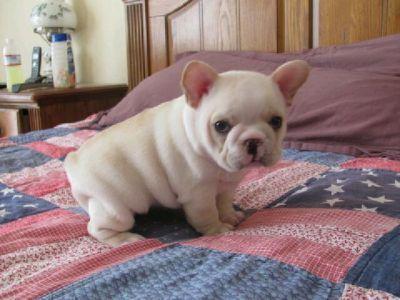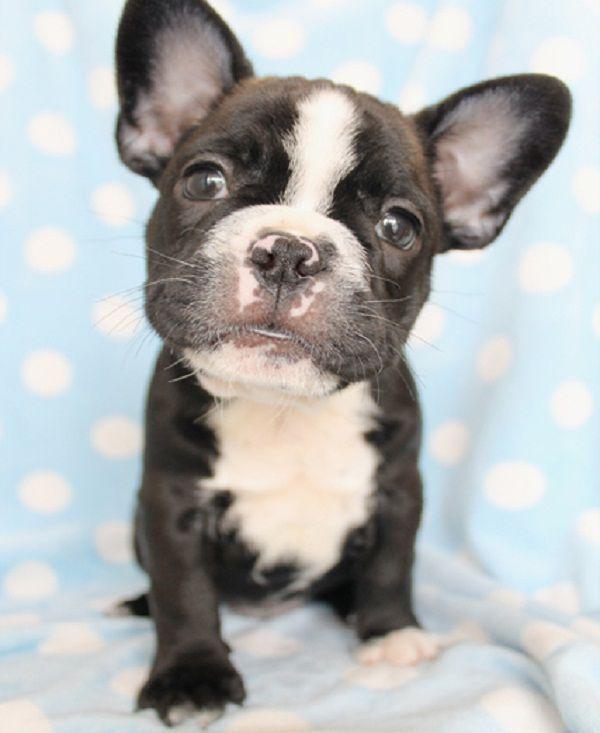The first image is the image on the left, the second image is the image on the right. Assess this claim about the two images: "At least one dog is wearing a collar.". Correct or not? Answer yes or no. No. The first image is the image on the left, the second image is the image on the right. For the images displayed, is the sentence "A dog is wearing a collar." factually correct? Answer yes or no. No. 